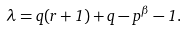Convert formula to latex. <formula><loc_0><loc_0><loc_500><loc_500>\lambda = q ( r + 1 ) + q - p ^ { \beta } - 1 .</formula> 